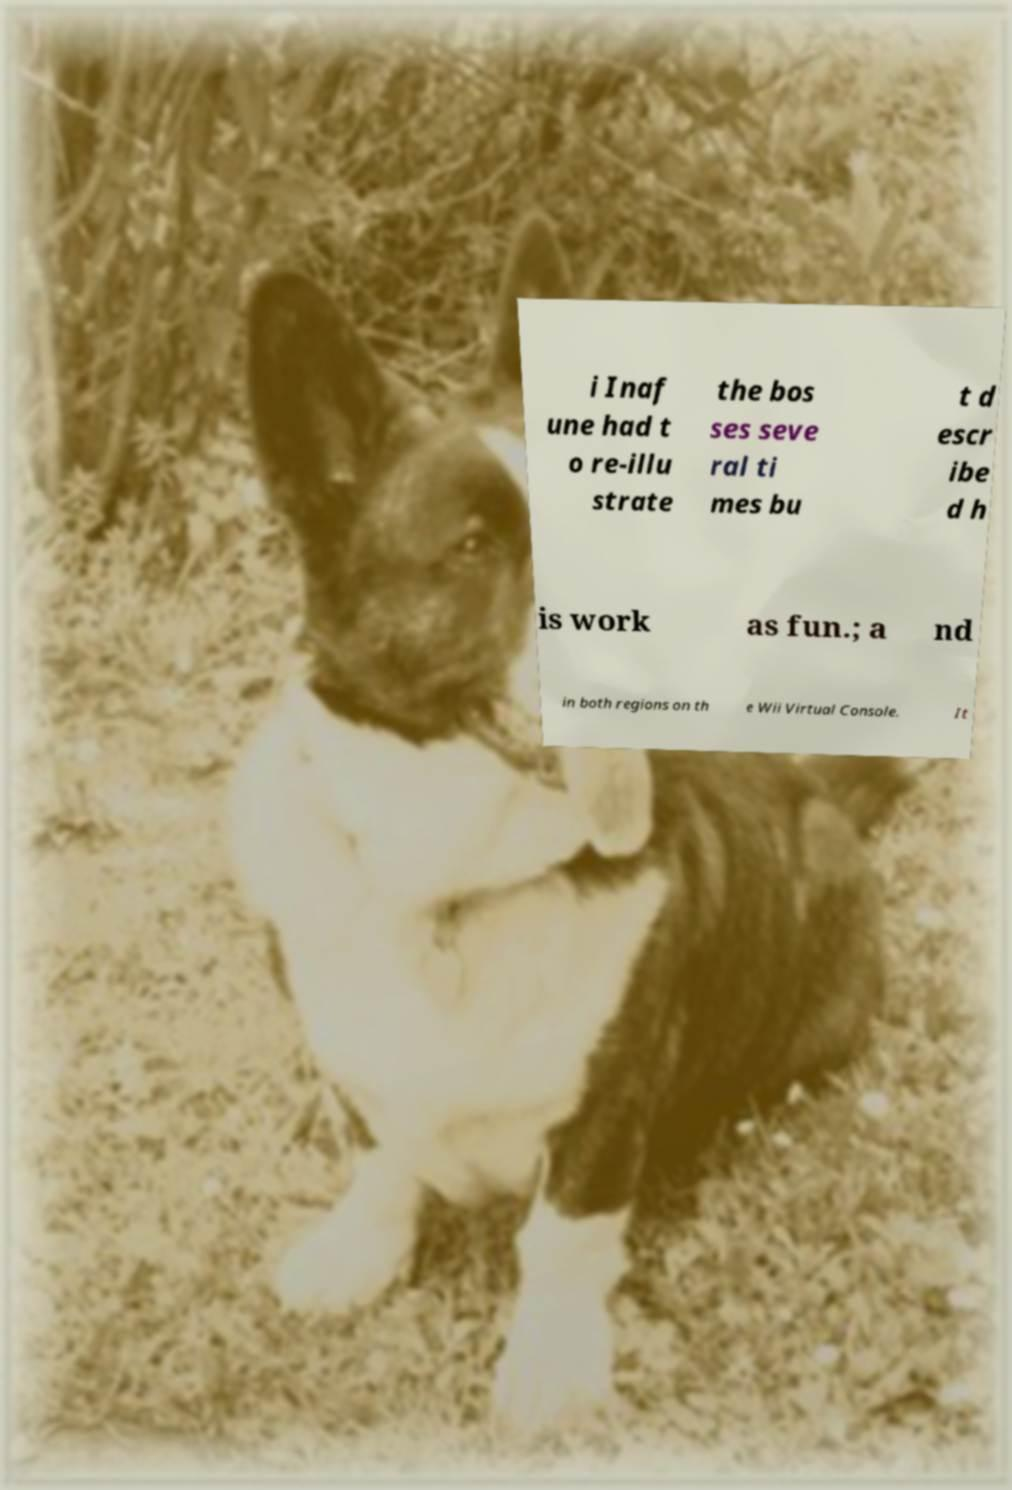Can you accurately transcribe the text from the provided image for me? i Inaf une had t o re-illu strate the bos ses seve ral ti mes bu t d escr ibe d h is work as fun.; a nd in both regions on th e Wii Virtual Console. It 